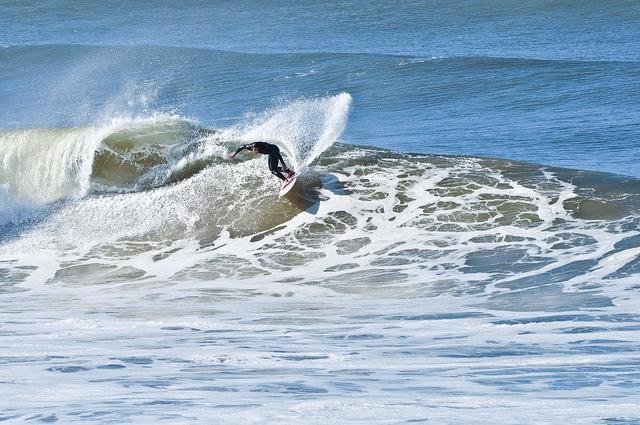How many arms is this man holding in the air?
Give a very brief answer. 1. 